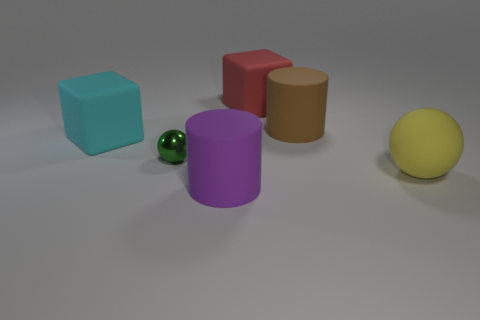There is a brown matte cylinder; is its size the same as the ball that is to the left of the large matte sphere? No, the brown matte cylinder is not the same size as the ball to the left of the large matte sphere; the cylinder is taller in height and has a different shape, being cylindrical as opposed to the spherical shape of the ball. 